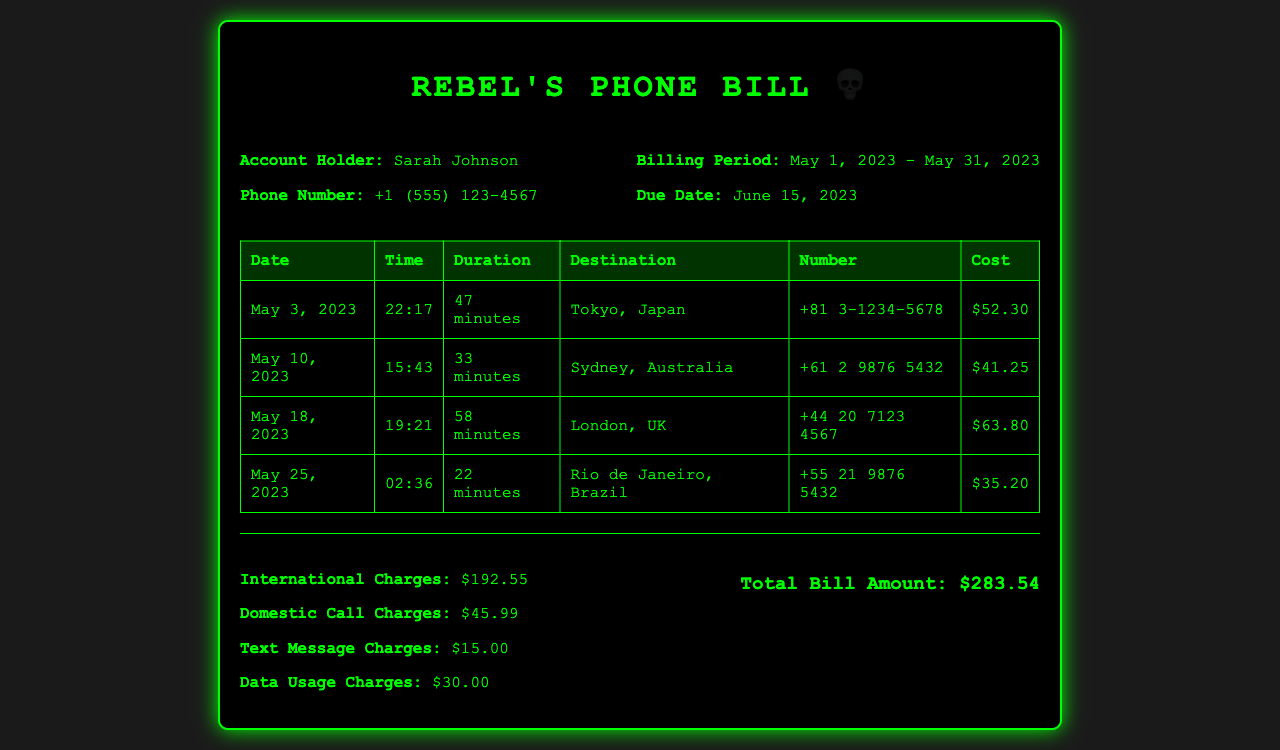what is the account holder's name? The document states that the account holder is Sarah Johnson.
Answer: Sarah Johnson what is the total international charges? The total international charges are listed in the summary section of the document as $192.55.
Answer: $192.55 how many minutes was the longest call? The longest call was to London, which lasted 58 minutes.
Answer: 58 minutes what was the cost of the call to Tokyo? The document lists the cost for the call to Tokyo on May 3, 2023, as $52.30.
Answer: $52.30 what is the phone number of the call to Sydney? The document shows the phone number for the call to Sydney as +61 2 9876 5432.
Answer: +61 2 9876 5432 what is the total bill amount? The total bill amount is calculated from the summary and is stated as $283.54.
Answer: $283.54 which country had the least expensive call? The least expensive call listed was to Rio de Janeiro, Brazil, costing $35.20.
Answer: Brazil when is the due date for the phone bill? The due date for the phone bill is June 15, 2023, as indicated in the document.
Answer: June 15, 2023 how many international calls are listed? The document contains a total of four international calls made during the billing period.
Answer: Four 